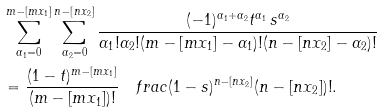<formula> <loc_0><loc_0><loc_500><loc_500>& \sum _ { \alpha _ { 1 } = 0 } ^ { m - [ m x _ { 1 } ] } \sum _ { \alpha _ { 2 } = 0 } ^ { n - [ n x _ { 2 } ] } \frac { ( - 1 ) ^ { \alpha _ { 1 } + \alpha _ { 2 } } t ^ { \alpha _ { 1 } } \, s ^ { \alpha _ { 2 } } } { \alpha _ { 1 } ! \alpha _ { 2 } ! ( m - [ m x _ { 1 } ] - \alpha _ { 1 } ) ! ( n - [ n x _ { 2 } ] - \alpha _ { 2 } ) ! } \\ & = \frac { ( 1 - t ) ^ { m - [ m x _ { 1 } ] } } { ( m - [ m x _ { 1 } ] ) ! } \ \ \ f r a c { ( 1 - s ) ^ { n - [ n x _ { 2 } ] } } { ( n - [ n x _ { 2 } ] ) ! } .</formula> 